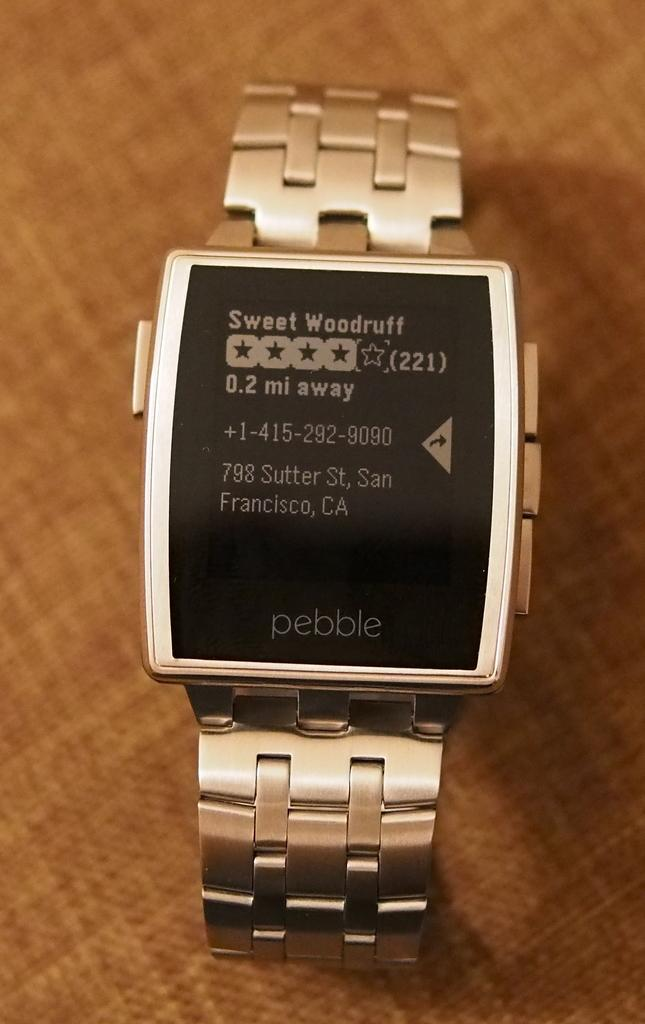<image>
Provide a brief description of the given image. A smart watch says "pebble" at the bottom of the screen. 